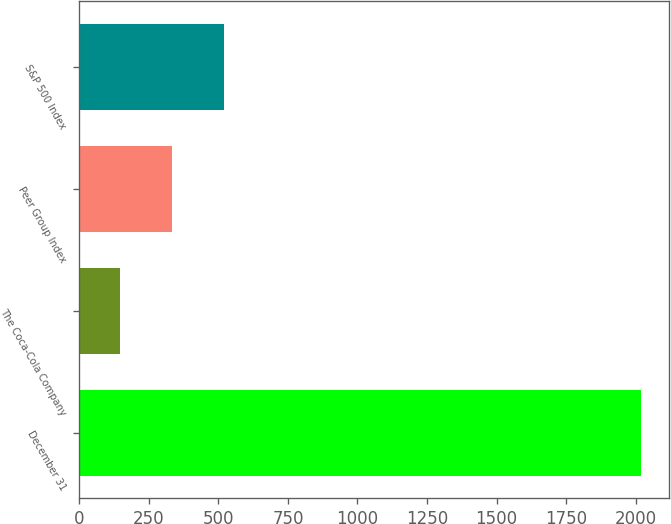Convert chart to OTSL. <chart><loc_0><loc_0><loc_500><loc_500><bar_chart><fcel>December 31<fcel>The Coca-Cola Company<fcel>Peer Group Index<fcel>S&P 500 Index<nl><fcel>2017<fcel>148<fcel>334.9<fcel>521.8<nl></chart> 